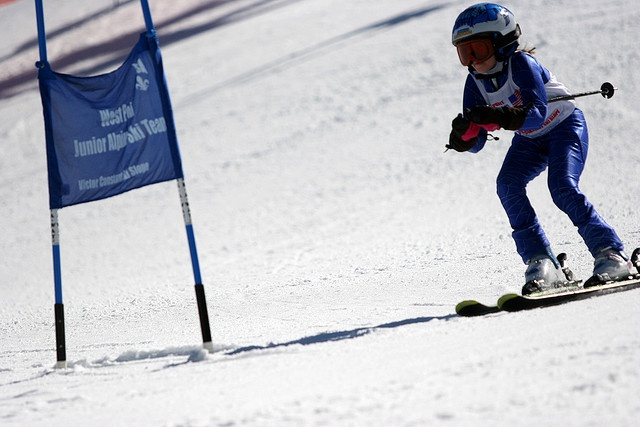Describe the objects in this image and their specific colors. I can see people in brown, black, navy, gray, and lightgray tones and skis in brown, black, ivory, darkgray, and gray tones in this image. 